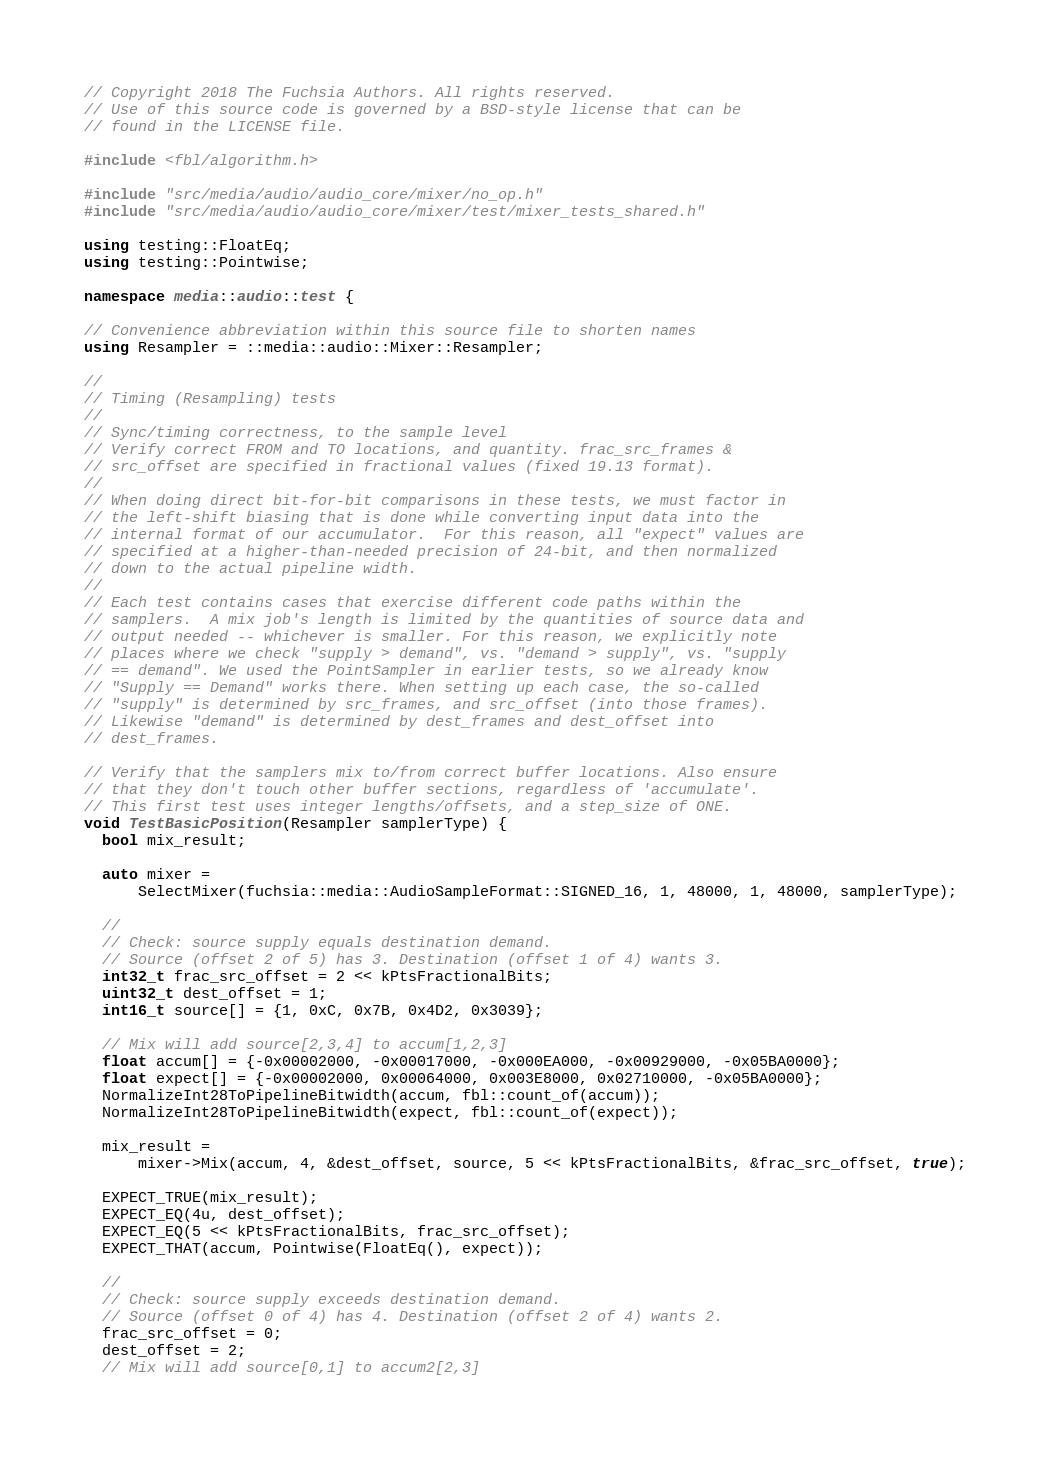<code> <loc_0><loc_0><loc_500><loc_500><_C++_>// Copyright 2018 The Fuchsia Authors. All rights reserved.
// Use of this source code is governed by a BSD-style license that can be
// found in the LICENSE file.

#include <fbl/algorithm.h>

#include "src/media/audio/audio_core/mixer/no_op.h"
#include "src/media/audio/audio_core/mixer/test/mixer_tests_shared.h"

using testing::FloatEq;
using testing::Pointwise;

namespace media::audio::test {

// Convenience abbreviation within this source file to shorten names
using Resampler = ::media::audio::Mixer::Resampler;

//
// Timing (Resampling) tests
//
// Sync/timing correctness, to the sample level
// Verify correct FROM and TO locations, and quantity. frac_src_frames &
// src_offset are specified in fractional values (fixed 19.13 format).
//
// When doing direct bit-for-bit comparisons in these tests, we must factor in
// the left-shift biasing that is done while converting input data into the
// internal format of our accumulator.  For this reason, all "expect" values are
// specified at a higher-than-needed precision of 24-bit, and then normalized
// down to the actual pipeline width.
//
// Each test contains cases that exercise different code paths within the
// samplers.  A mix job's length is limited by the quantities of source data and
// output needed -- whichever is smaller. For this reason, we explicitly note
// places where we check "supply > demand", vs. "demand > supply", vs. "supply
// == demand". We used the PointSampler in earlier tests, so we already know
// "Supply == Demand" works there. When setting up each case, the so-called
// "supply" is determined by src_frames, and src_offset (into those frames).
// Likewise "demand" is determined by dest_frames and dest_offset into
// dest_frames.

// Verify that the samplers mix to/from correct buffer locations. Also ensure
// that they don't touch other buffer sections, regardless of 'accumulate'.
// This first test uses integer lengths/offsets, and a step_size of ONE.
void TestBasicPosition(Resampler samplerType) {
  bool mix_result;

  auto mixer =
      SelectMixer(fuchsia::media::AudioSampleFormat::SIGNED_16, 1, 48000, 1, 48000, samplerType);

  //
  // Check: source supply equals destination demand.
  // Source (offset 2 of 5) has 3. Destination (offset 1 of 4) wants 3.
  int32_t frac_src_offset = 2 << kPtsFractionalBits;
  uint32_t dest_offset = 1;
  int16_t source[] = {1, 0xC, 0x7B, 0x4D2, 0x3039};

  // Mix will add source[2,3,4] to accum[1,2,3]
  float accum[] = {-0x00002000, -0x00017000, -0x000EA000, -0x00929000, -0x05BA0000};
  float expect[] = {-0x00002000, 0x00064000, 0x003E8000, 0x02710000, -0x05BA0000};
  NormalizeInt28ToPipelineBitwidth(accum, fbl::count_of(accum));
  NormalizeInt28ToPipelineBitwidth(expect, fbl::count_of(expect));

  mix_result =
      mixer->Mix(accum, 4, &dest_offset, source, 5 << kPtsFractionalBits, &frac_src_offset, true);

  EXPECT_TRUE(mix_result);
  EXPECT_EQ(4u, dest_offset);
  EXPECT_EQ(5 << kPtsFractionalBits, frac_src_offset);
  EXPECT_THAT(accum, Pointwise(FloatEq(), expect));

  //
  // Check: source supply exceeds destination demand.
  // Source (offset 0 of 4) has 4. Destination (offset 2 of 4) wants 2.
  frac_src_offset = 0;
  dest_offset = 2;
  // Mix will add source[0,1] to accum2[2,3]</code> 